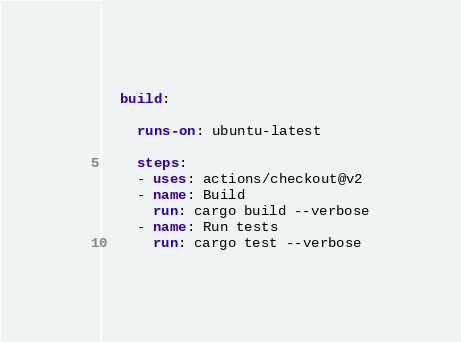<code> <loc_0><loc_0><loc_500><loc_500><_YAML_>  build:

    runs-on: ubuntu-latest

    steps:
    - uses: actions/checkout@v2
    - name: Build
      run: cargo build --verbose
    - name: Run tests
      run: cargo test --verbose
</code> 